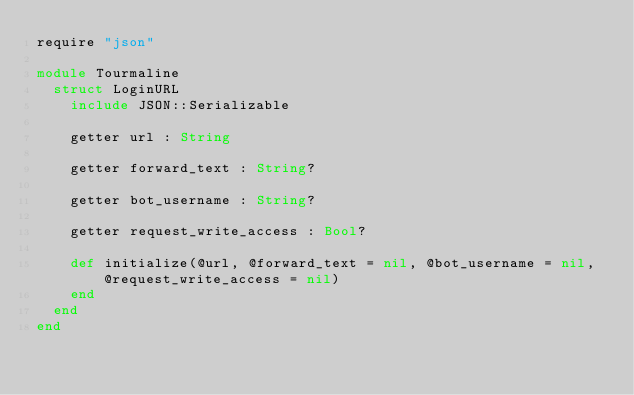<code> <loc_0><loc_0><loc_500><loc_500><_Crystal_>require "json"

module Tourmaline
  struct LoginURL
    include JSON::Serializable

    getter url : String

    getter forward_text : String?

    getter bot_username : String?

    getter request_write_access : Bool?

    def initialize(@url, @forward_text = nil, @bot_username = nil, @request_write_access = nil)
    end
  end
end
</code> 